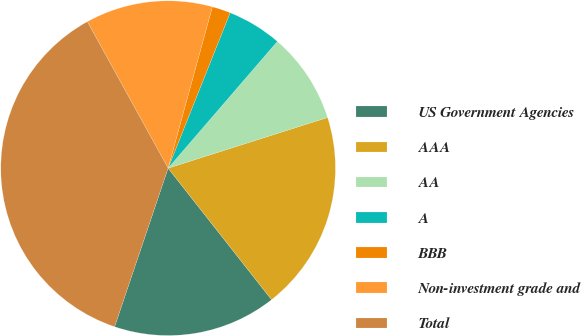Convert chart to OTSL. <chart><loc_0><loc_0><loc_500><loc_500><pie_chart><fcel>US Government Agencies<fcel>AAA<fcel>AA<fcel>A<fcel>BBB<fcel>Non-investment grade and<fcel>Total<nl><fcel>15.79%<fcel>19.29%<fcel>8.78%<fcel>5.28%<fcel>1.78%<fcel>12.28%<fcel>36.8%<nl></chart> 